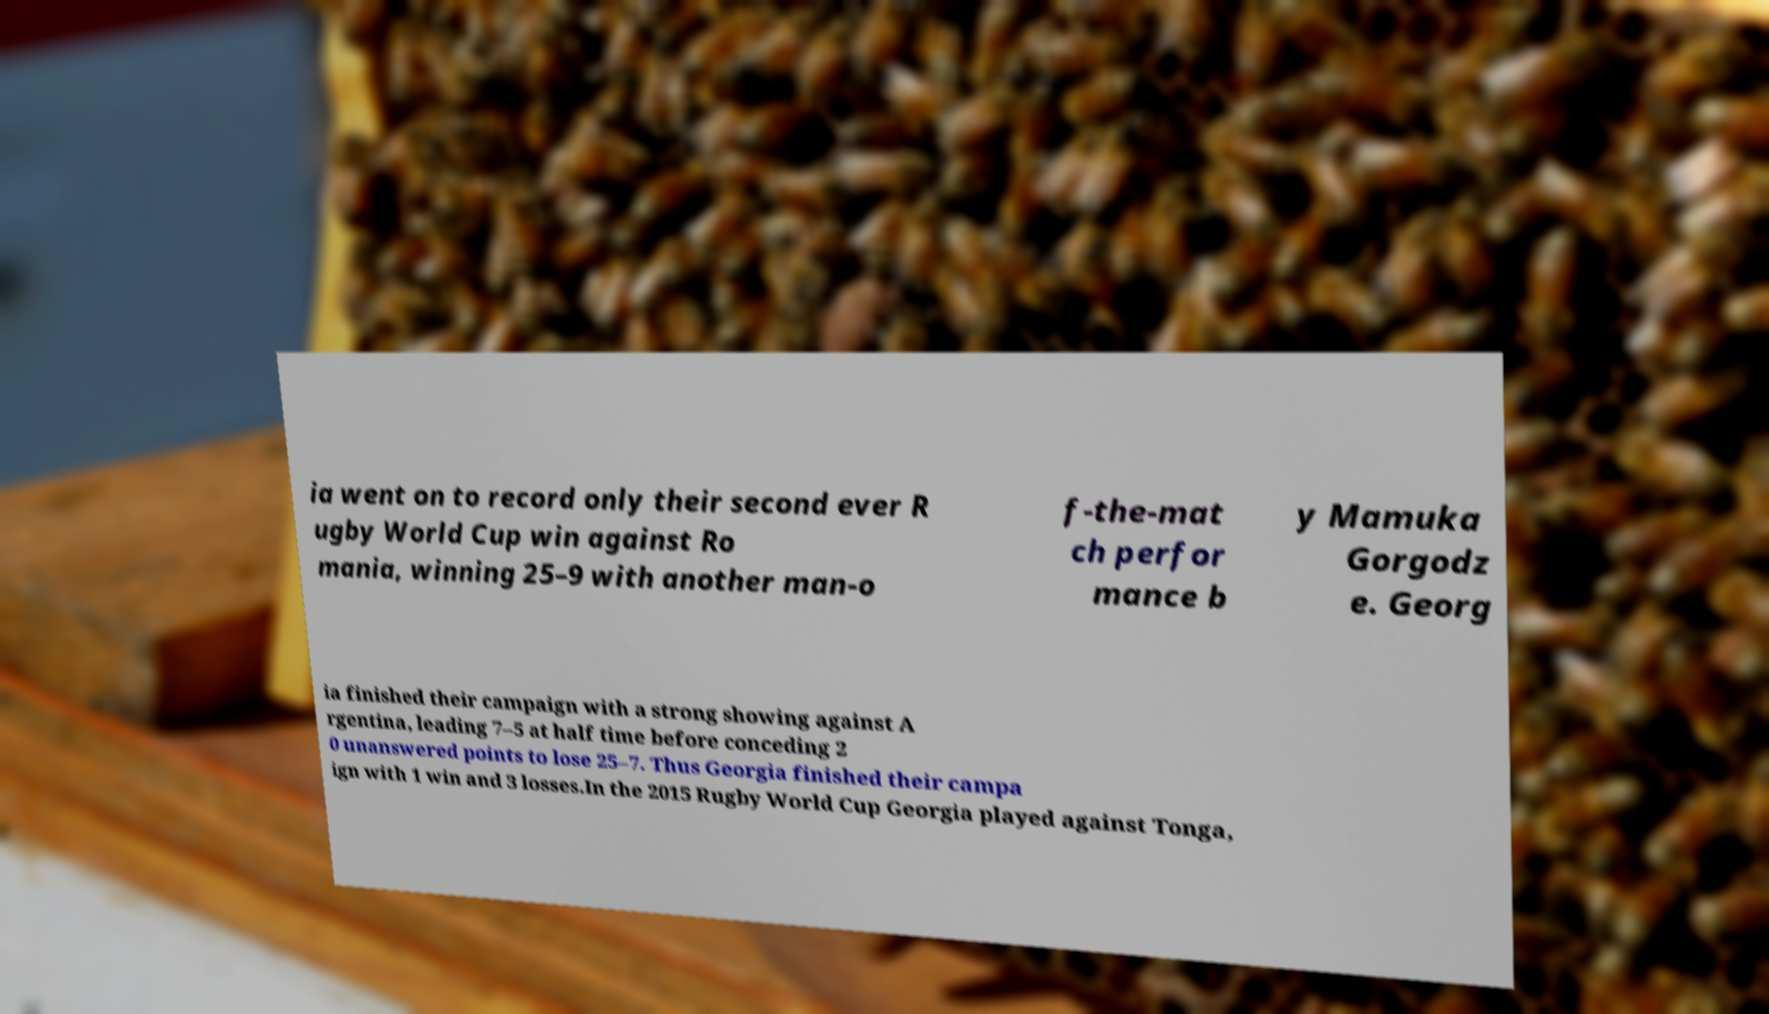Could you extract and type out the text from this image? ia went on to record only their second ever R ugby World Cup win against Ro mania, winning 25–9 with another man-o f-the-mat ch perfor mance b y Mamuka Gorgodz e. Georg ia finished their campaign with a strong showing against A rgentina, leading 7–5 at half time before conceding 2 0 unanswered points to lose 25–7. Thus Georgia finished their campa ign with 1 win and 3 losses.In the 2015 Rugby World Cup Georgia played against Tonga, 